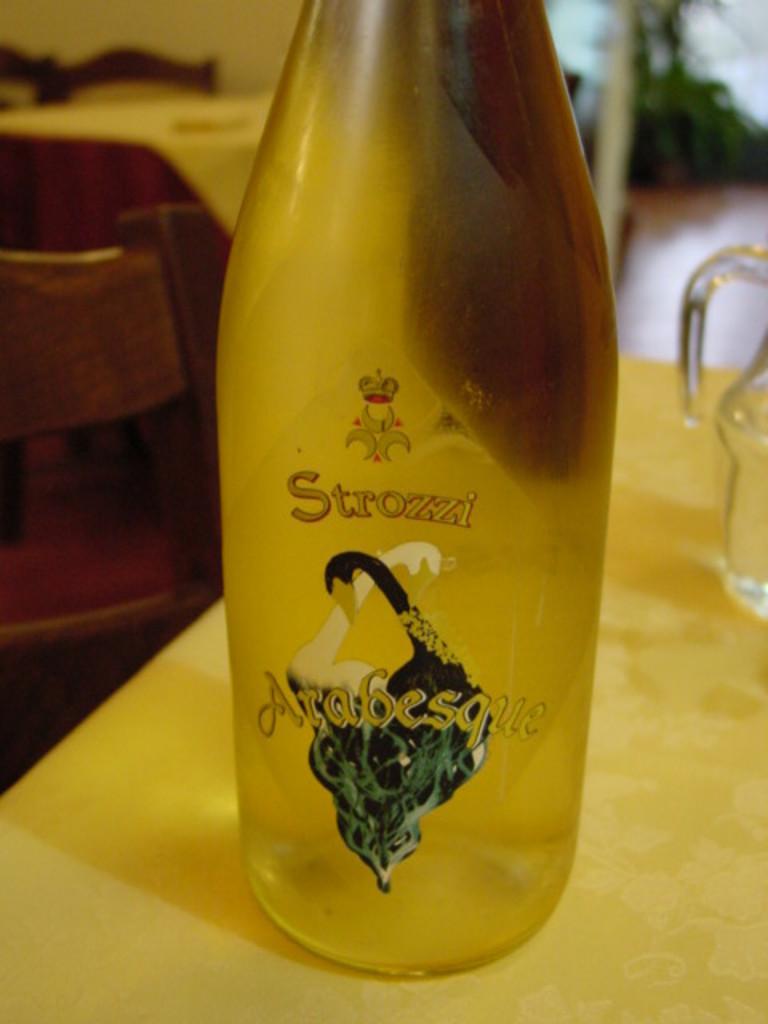Could you give a brief overview of what you see in this image? In the center of the image there is a bottle placed on a table. There is also a mug which is placed on a table. In the background there are some chairs as well. 